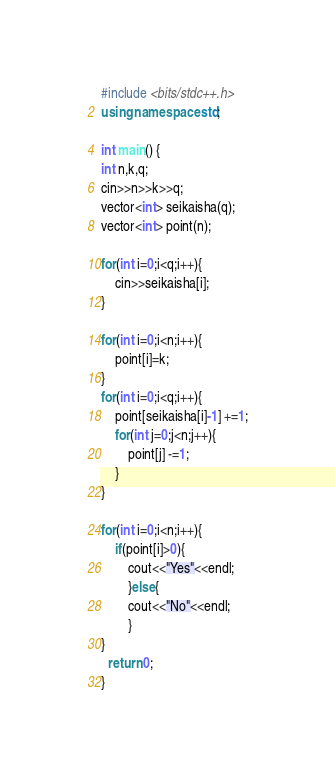Convert code to text. <code><loc_0><loc_0><loc_500><loc_500><_C++_>#include <bits/stdc++.h>
using namespace std;
 
int main() {
int n,k,q;
cin>>n>>k>>q;
vector<int> seikaisha(q);
vector<int> point(n);

for(int i=0;i<q;i++){
	cin>>seikaisha[i];
}

for(int i=0;i<n;i++){
	point[i]=k;
}
for(int i=0;i<q;i++){
	point[seikaisha[i]-1] +=1;
  	for(int j=0;j<n;j++){
		point[j] -=1;
    }
}

for(int i=0;i<n;i++){
	if(point[i]>0){
		cout<<"Yes"<<endl;
		}else{
		cout<<"No"<<endl;
		}
}
  return 0;
}</code> 